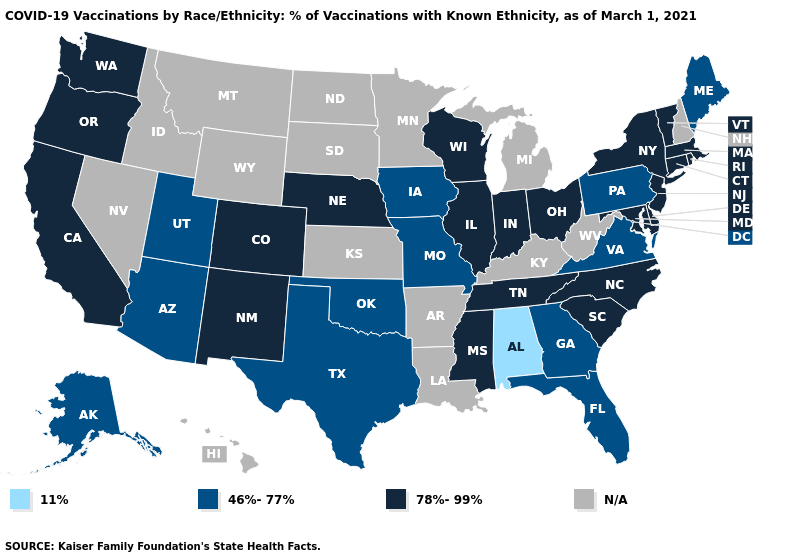Name the states that have a value in the range 78%-99%?
Write a very short answer. California, Colorado, Connecticut, Delaware, Illinois, Indiana, Maryland, Massachusetts, Mississippi, Nebraska, New Jersey, New Mexico, New York, North Carolina, Ohio, Oregon, Rhode Island, South Carolina, Tennessee, Vermont, Washington, Wisconsin. What is the highest value in the South ?
Write a very short answer. 78%-99%. Name the states that have a value in the range N/A?
Be succinct. Arkansas, Hawaii, Idaho, Kansas, Kentucky, Louisiana, Michigan, Minnesota, Montana, Nevada, New Hampshire, North Dakota, South Dakota, West Virginia, Wyoming. Name the states that have a value in the range 11%?
Quick response, please. Alabama. What is the lowest value in the USA?
Short answer required. 11%. Name the states that have a value in the range 78%-99%?
Write a very short answer. California, Colorado, Connecticut, Delaware, Illinois, Indiana, Maryland, Massachusetts, Mississippi, Nebraska, New Jersey, New Mexico, New York, North Carolina, Ohio, Oregon, Rhode Island, South Carolina, Tennessee, Vermont, Washington, Wisconsin. Does Alabama have the lowest value in the USA?
Concise answer only. Yes. Name the states that have a value in the range 78%-99%?
Quick response, please. California, Colorado, Connecticut, Delaware, Illinois, Indiana, Maryland, Massachusetts, Mississippi, Nebraska, New Jersey, New Mexico, New York, North Carolina, Ohio, Oregon, Rhode Island, South Carolina, Tennessee, Vermont, Washington, Wisconsin. What is the lowest value in states that border Pennsylvania?
Give a very brief answer. 78%-99%. Name the states that have a value in the range 11%?
Concise answer only. Alabama. Name the states that have a value in the range N/A?
Keep it brief. Arkansas, Hawaii, Idaho, Kansas, Kentucky, Louisiana, Michigan, Minnesota, Montana, Nevada, New Hampshire, North Dakota, South Dakota, West Virginia, Wyoming. Name the states that have a value in the range 11%?
Answer briefly. Alabama. What is the value of Kentucky?
Write a very short answer. N/A. 